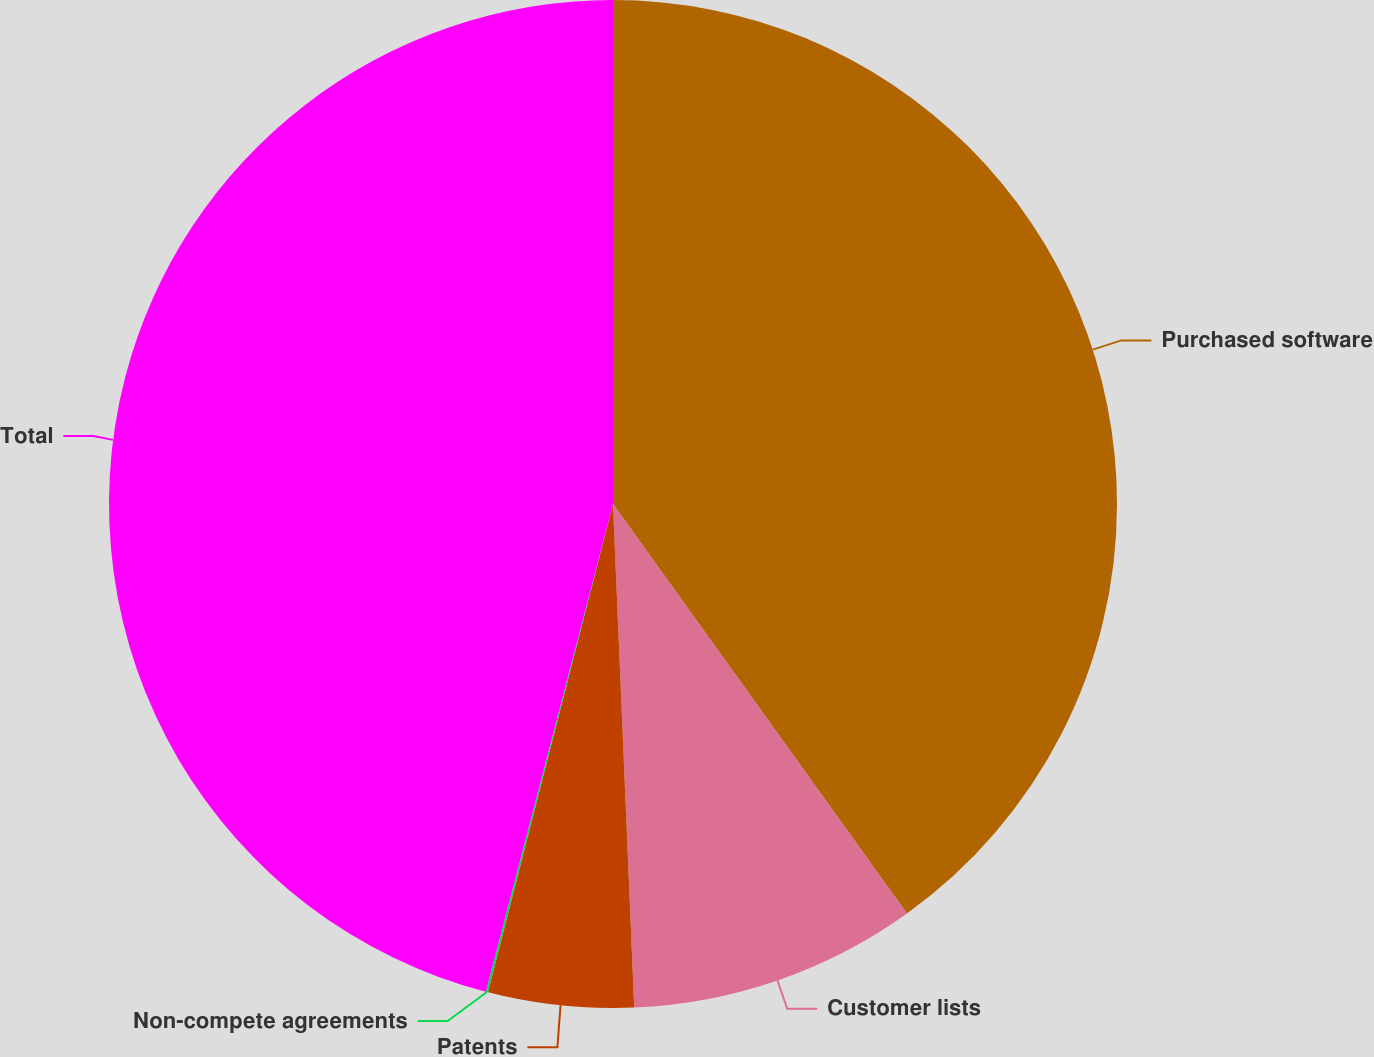<chart> <loc_0><loc_0><loc_500><loc_500><pie_chart><fcel>Purchased software<fcel>Customer lists<fcel>Patents<fcel>Non-compete agreements<fcel>Total<nl><fcel>40.09%<fcel>9.24%<fcel>4.66%<fcel>0.07%<fcel>45.94%<nl></chart> 